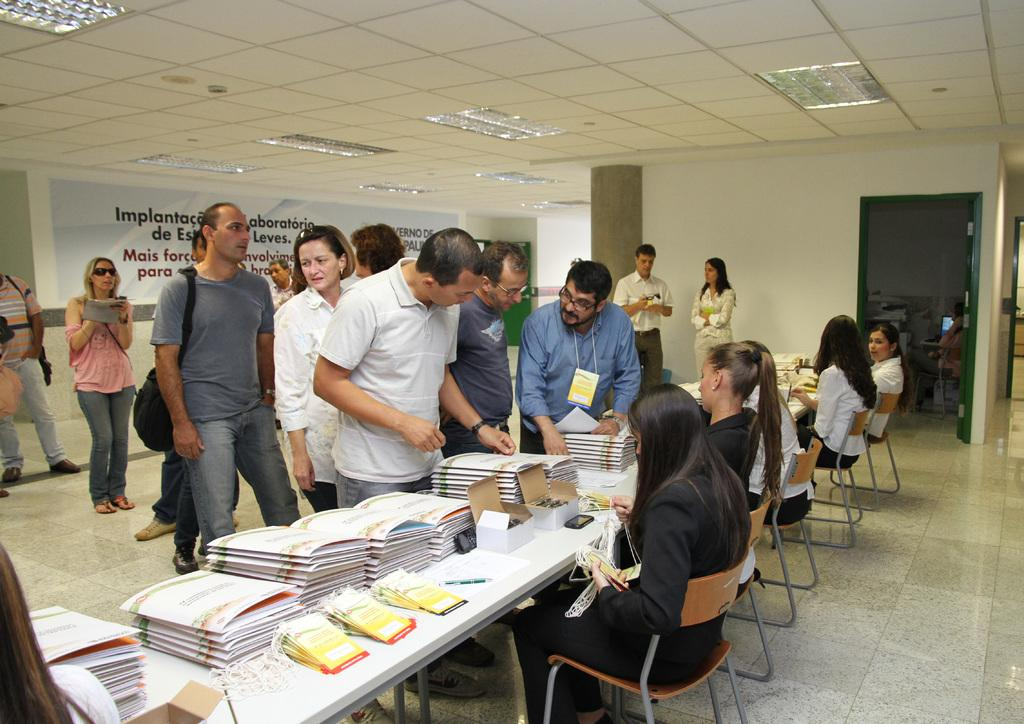What is the primary activity of the people in the image? The people in the image are standing and sitting. Can you describe the positions of the women in the image? The women are sitting on chairs in the image. How are the women positioned in relation to the standing people? The women are in front of the standing people. What is present on the table in the image? There are books on the table in the image. What type of orange is being used as a pocket in the image? There is no orange or pocket present in the image. What drink is being consumed by the people in the image? The provided facts do not mention any drinks being consumed by the people in the image. 